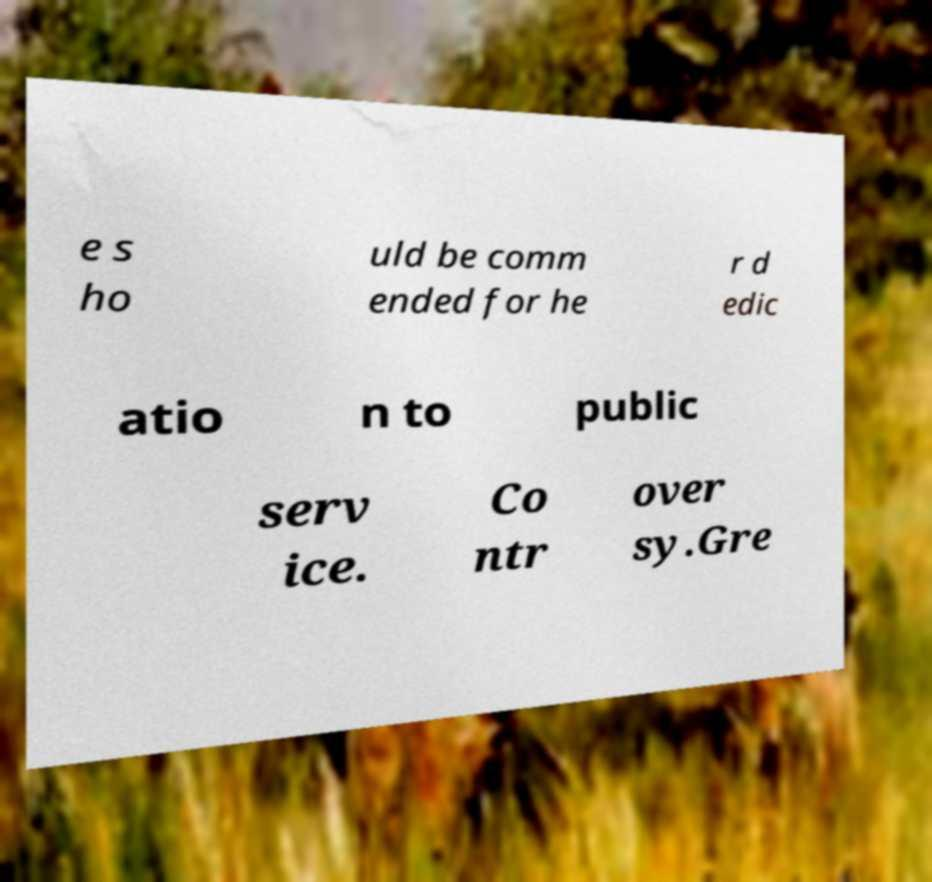Please read and relay the text visible in this image. What does it say? e s ho uld be comm ended for he r d edic atio n to public serv ice. Co ntr over sy.Gre 